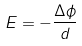<formula> <loc_0><loc_0><loc_500><loc_500>E = - \frac { \Delta \phi } { d }</formula> 